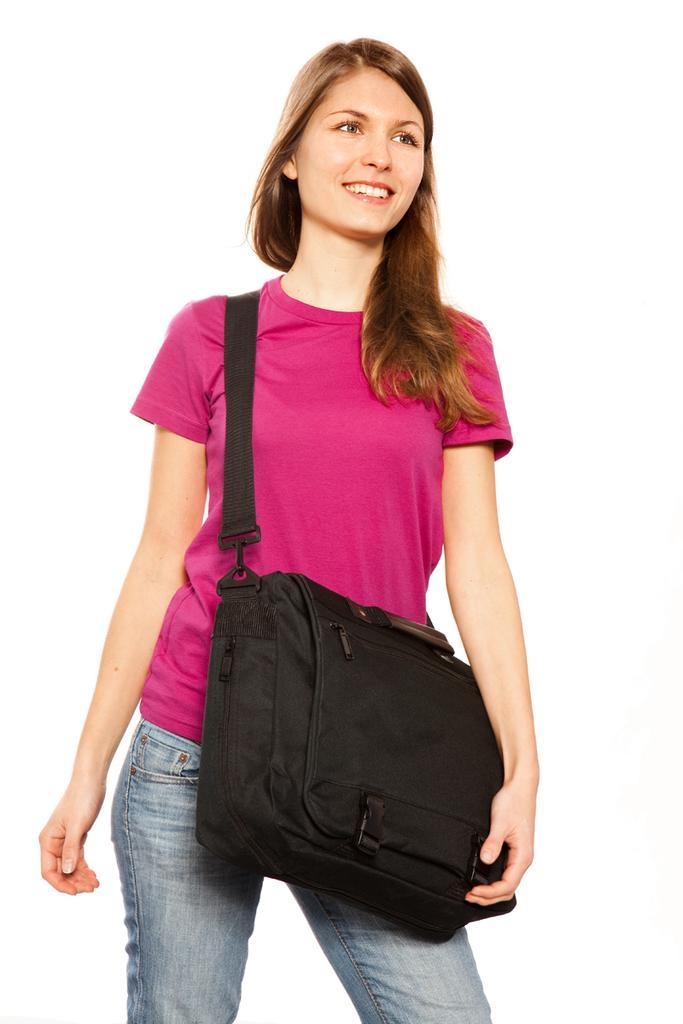Can you describe this image briefly? In this image there is a woman standing with a bag. She is wearing pink color t shirt and blue jeans. 